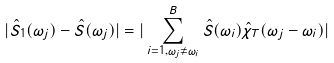Convert formula to latex. <formula><loc_0><loc_0><loc_500><loc_500>| \hat { S } _ { 1 } ( \omega _ { j } ) - \hat { S } ( \omega _ { j } ) | = | \sum _ { i = 1 , \omega _ { j } \neq \omega _ { i } } ^ { B } \hat { S } ( \omega _ { i } ) \hat { \chi } _ { T } ( \omega _ { j } - \omega _ { i } ) |</formula> 